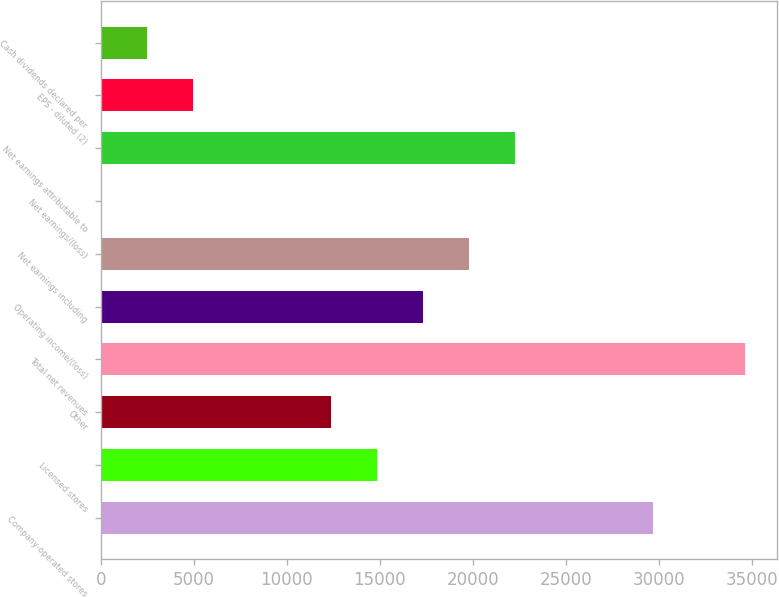<chart> <loc_0><loc_0><loc_500><loc_500><bar_chart><fcel>Company-operated stores<fcel>Licensed stores<fcel>Other<fcel>Total net revenues<fcel>Operating income/(loss)<fcel>Net earnings including<fcel>Net earnings/(loss)<fcel>Net earnings attributable to<fcel>EPS - diluted (2)<fcel>Cash dividends declared per<nl><fcel>29663.3<fcel>14831.8<fcel>12359.9<fcel>34607.2<fcel>17303.7<fcel>19775.7<fcel>0.3<fcel>22247.6<fcel>4944.14<fcel>2472.22<nl></chart> 